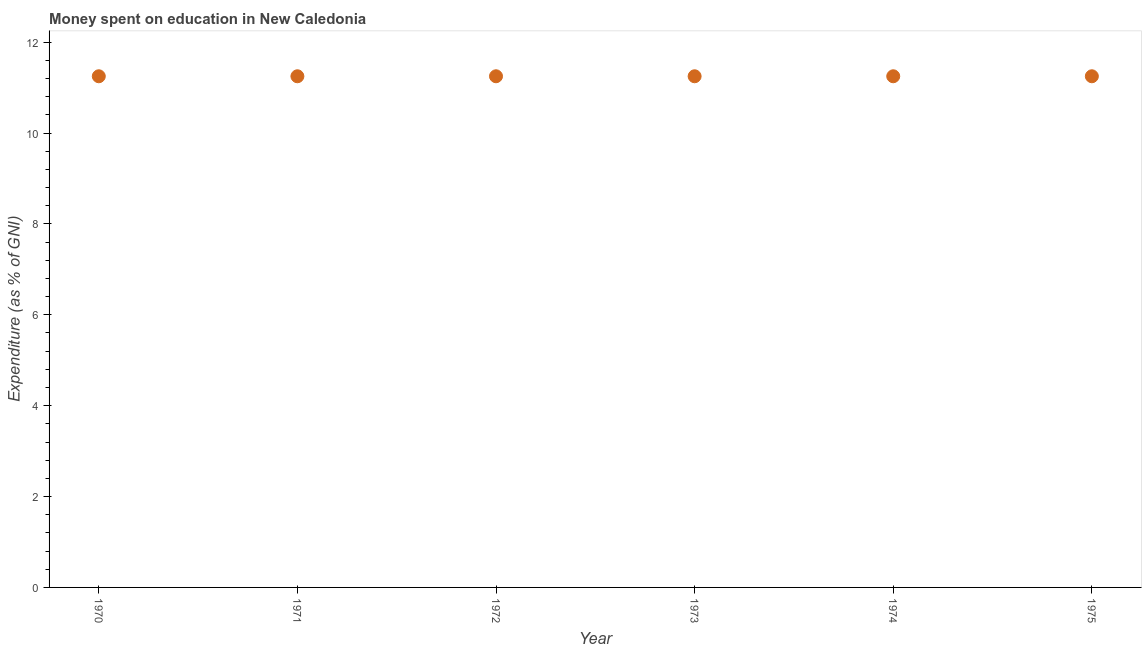What is the expenditure on education in 1972?
Make the answer very short. 11.25. Across all years, what is the maximum expenditure on education?
Give a very brief answer. 11.25. Across all years, what is the minimum expenditure on education?
Give a very brief answer. 11.25. What is the sum of the expenditure on education?
Keep it short and to the point. 67.49. What is the average expenditure on education per year?
Keep it short and to the point. 11.25. What is the median expenditure on education?
Offer a terse response. 11.25. Do a majority of the years between 1975 and 1971 (inclusive) have expenditure on education greater than 7.2 %?
Give a very brief answer. Yes. In how many years, is the expenditure on education greater than the average expenditure on education taken over all years?
Give a very brief answer. 0. Does the expenditure on education monotonically increase over the years?
Your answer should be compact. No. How many dotlines are there?
Your response must be concise. 1. What is the difference between two consecutive major ticks on the Y-axis?
Your answer should be very brief. 2. What is the title of the graph?
Give a very brief answer. Money spent on education in New Caledonia. What is the label or title of the X-axis?
Your answer should be compact. Year. What is the label or title of the Y-axis?
Your answer should be very brief. Expenditure (as % of GNI). What is the Expenditure (as % of GNI) in 1970?
Your answer should be very brief. 11.25. What is the Expenditure (as % of GNI) in 1971?
Keep it short and to the point. 11.25. What is the Expenditure (as % of GNI) in 1972?
Make the answer very short. 11.25. What is the Expenditure (as % of GNI) in 1973?
Your answer should be compact. 11.25. What is the Expenditure (as % of GNI) in 1974?
Offer a terse response. 11.25. What is the Expenditure (as % of GNI) in 1975?
Your answer should be very brief. 11.25. What is the difference between the Expenditure (as % of GNI) in 1970 and 1971?
Ensure brevity in your answer.  0. What is the difference between the Expenditure (as % of GNI) in 1970 and 1972?
Offer a terse response. 0. What is the difference between the Expenditure (as % of GNI) in 1970 and 1975?
Ensure brevity in your answer.  0. What is the difference between the Expenditure (as % of GNI) in 1971 and 1975?
Provide a short and direct response. 0. What is the difference between the Expenditure (as % of GNI) in 1972 and 1973?
Your response must be concise. 0. What is the difference between the Expenditure (as % of GNI) in 1972 and 1974?
Your answer should be very brief. 0. What is the difference between the Expenditure (as % of GNI) in 1973 and 1974?
Give a very brief answer. 0. What is the ratio of the Expenditure (as % of GNI) in 1970 to that in 1971?
Make the answer very short. 1. What is the ratio of the Expenditure (as % of GNI) in 1970 to that in 1972?
Give a very brief answer. 1. What is the ratio of the Expenditure (as % of GNI) in 1970 to that in 1973?
Provide a short and direct response. 1. What is the ratio of the Expenditure (as % of GNI) in 1970 to that in 1974?
Give a very brief answer. 1. What is the ratio of the Expenditure (as % of GNI) in 1971 to that in 1975?
Offer a very short reply. 1. What is the ratio of the Expenditure (as % of GNI) in 1972 to that in 1973?
Offer a terse response. 1. What is the ratio of the Expenditure (as % of GNI) in 1972 to that in 1974?
Provide a succinct answer. 1. What is the ratio of the Expenditure (as % of GNI) in 1972 to that in 1975?
Keep it short and to the point. 1. 